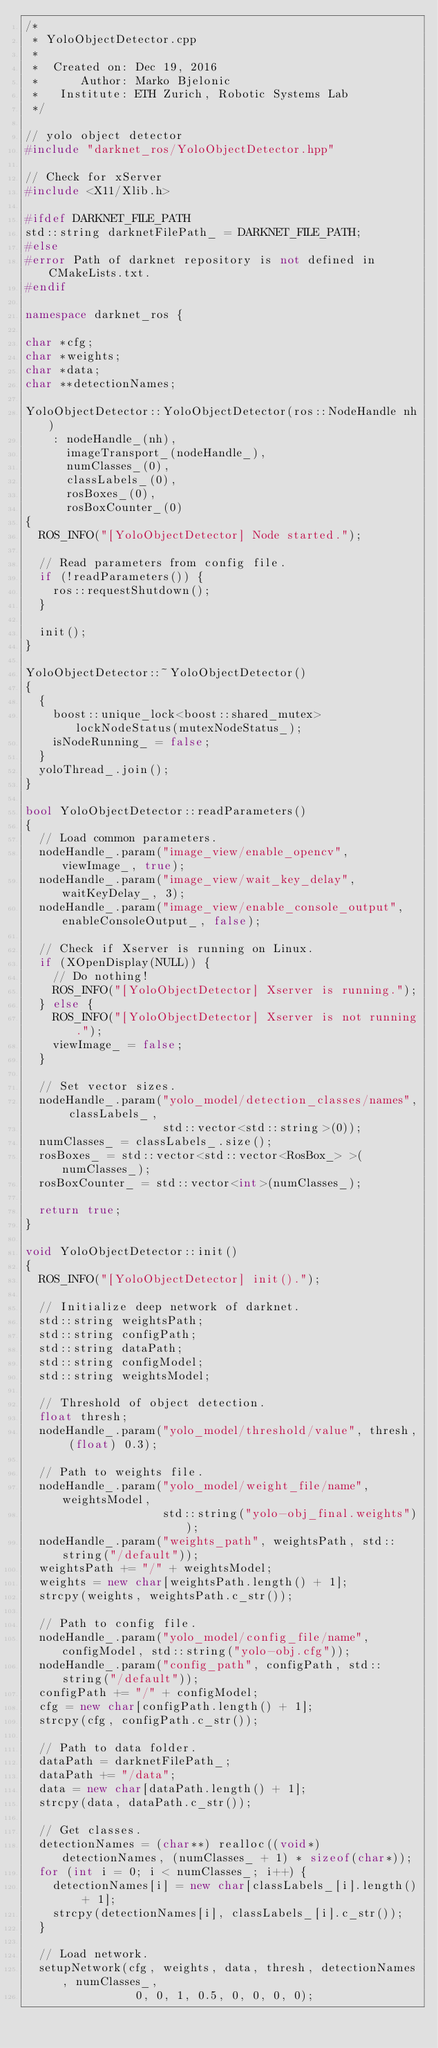Convert code to text. <code><loc_0><loc_0><loc_500><loc_500><_C++_>/*
 * YoloObjectDetector.cpp
 *
 *  Created on: Dec 19, 2016
 *      Author: Marko Bjelonic
 *   Institute: ETH Zurich, Robotic Systems Lab
 */

// yolo object detector
#include "darknet_ros/YoloObjectDetector.hpp"

// Check for xServer
#include <X11/Xlib.h>

#ifdef DARKNET_FILE_PATH
std::string darknetFilePath_ = DARKNET_FILE_PATH;
#else
#error Path of darknet repository is not defined in CMakeLists.txt.
#endif

namespace darknet_ros {

char *cfg;
char *weights;
char *data;
char **detectionNames;

YoloObjectDetector::YoloObjectDetector(ros::NodeHandle nh)
    : nodeHandle_(nh),
      imageTransport_(nodeHandle_),
      numClasses_(0),
      classLabels_(0),
      rosBoxes_(0),
      rosBoxCounter_(0)
{
  ROS_INFO("[YoloObjectDetector] Node started.");

  // Read parameters from config file.
  if (!readParameters()) {
    ros::requestShutdown();
  }

  init();
}

YoloObjectDetector::~YoloObjectDetector()
{
  {
    boost::unique_lock<boost::shared_mutex> lockNodeStatus(mutexNodeStatus_);
    isNodeRunning_ = false;
  }
  yoloThread_.join();
}

bool YoloObjectDetector::readParameters()
{
  // Load common parameters.
  nodeHandle_.param("image_view/enable_opencv", viewImage_, true);
  nodeHandle_.param("image_view/wait_key_delay", waitKeyDelay_, 3);
  nodeHandle_.param("image_view/enable_console_output", enableConsoleOutput_, false);

  // Check if Xserver is running on Linux.
  if (XOpenDisplay(NULL)) {
    // Do nothing!
    ROS_INFO("[YoloObjectDetector] Xserver is running.");
  } else {
    ROS_INFO("[YoloObjectDetector] Xserver is not running.");
    viewImage_ = false;
  }

  // Set vector sizes.
  nodeHandle_.param("yolo_model/detection_classes/names", classLabels_,
                    std::vector<std::string>(0));
  numClasses_ = classLabels_.size();
  rosBoxes_ = std::vector<std::vector<RosBox_> >(numClasses_);
  rosBoxCounter_ = std::vector<int>(numClasses_);

  return true;
}

void YoloObjectDetector::init()
{
  ROS_INFO("[YoloObjectDetector] init().");

  // Initialize deep network of darknet.
  std::string weightsPath;
  std::string configPath;
  std::string dataPath;
  std::string configModel;
  std::string weightsModel;

  // Threshold of object detection.
  float thresh;
  nodeHandle_.param("yolo_model/threshold/value", thresh, (float) 0.3);

  // Path to weights file.
  nodeHandle_.param("yolo_model/weight_file/name", weightsModel,
                    std::string("yolo-obj_final.weights"));
  nodeHandle_.param("weights_path", weightsPath, std::string("/default"));
  weightsPath += "/" + weightsModel;
  weights = new char[weightsPath.length() + 1];
  strcpy(weights, weightsPath.c_str());

  // Path to config file.
  nodeHandle_.param("yolo_model/config_file/name", configModel, std::string("yolo-obj.cfg"));
  nodeHandle_.param("config_path", configPath, std::string("/default"));
  configPath += "/" + configModel;
  cfg = new char[configPath.length() + 1];
  strcpy(cfg, configPath.c_str());

  // Path to data folder.
  dataPath = darknetFilePath_;
  dataPath += "/data";
  data = new char[dataPath.length() + 1];
  strcpy(data, dataPath.c_str());

  // Get classes.
  detectionNames = (char**) realloc((void*) detectionNames, (numClasses_ + 1) * sizeof(char*));
  for (int i = 0; i < numClasses_; i++) {
    detectionNames[i] = new char[classLabels_[i].length() + 1];
    strcpy(detectionNames[i], classLabels_[i].c_str());
  }

  // Load network.
  setupNetwork(cfg, weights, data, thresh, detectionNames, numClasses_,
                0, 0, 1, 0.5, 0, 0, 0, 0);</code> 